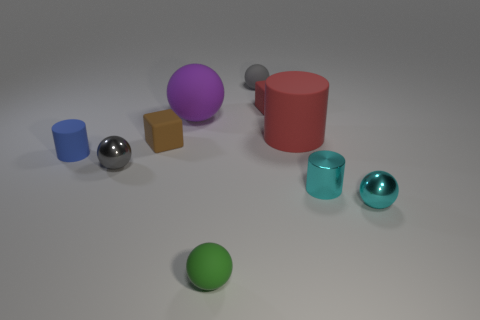There is a tiny gray object that is in front of the big purple matte object; what shape is it?
Offer a terse response. Sphere. There is a shiny thing that is in front of the tiny cyan shiny cylinder; is its color the same as the cylinder that is on the right side of the big cylinder?
Make the answer very short. Yes. What number of balls are both in front of the purple rubber ball and on the right side of the gray metallic thing?
Your response must be concise. 2. What is the size of the red object that is the same material as the red cube?
Your response must be concise. Large. How big is the purple thing?
Offer a terse response. Large. What is the material of the red block?
Offer a very short reply. Rubber. Is the size of the matte thing that is in front of the cyan metallic sphere the same as the red cube?
Your answer should be compact. Yes. How many things are blue cylinders or red objects?
Your answer should be very brief. 3. There is a small matte object that is the same color as the large matte cylinder; what shape is it?
Offer a terse response. Cube. What is the size of the matte sphere that is both in front of the red block and behind the red rubber cylinder?
Your response must be concise. Large. 